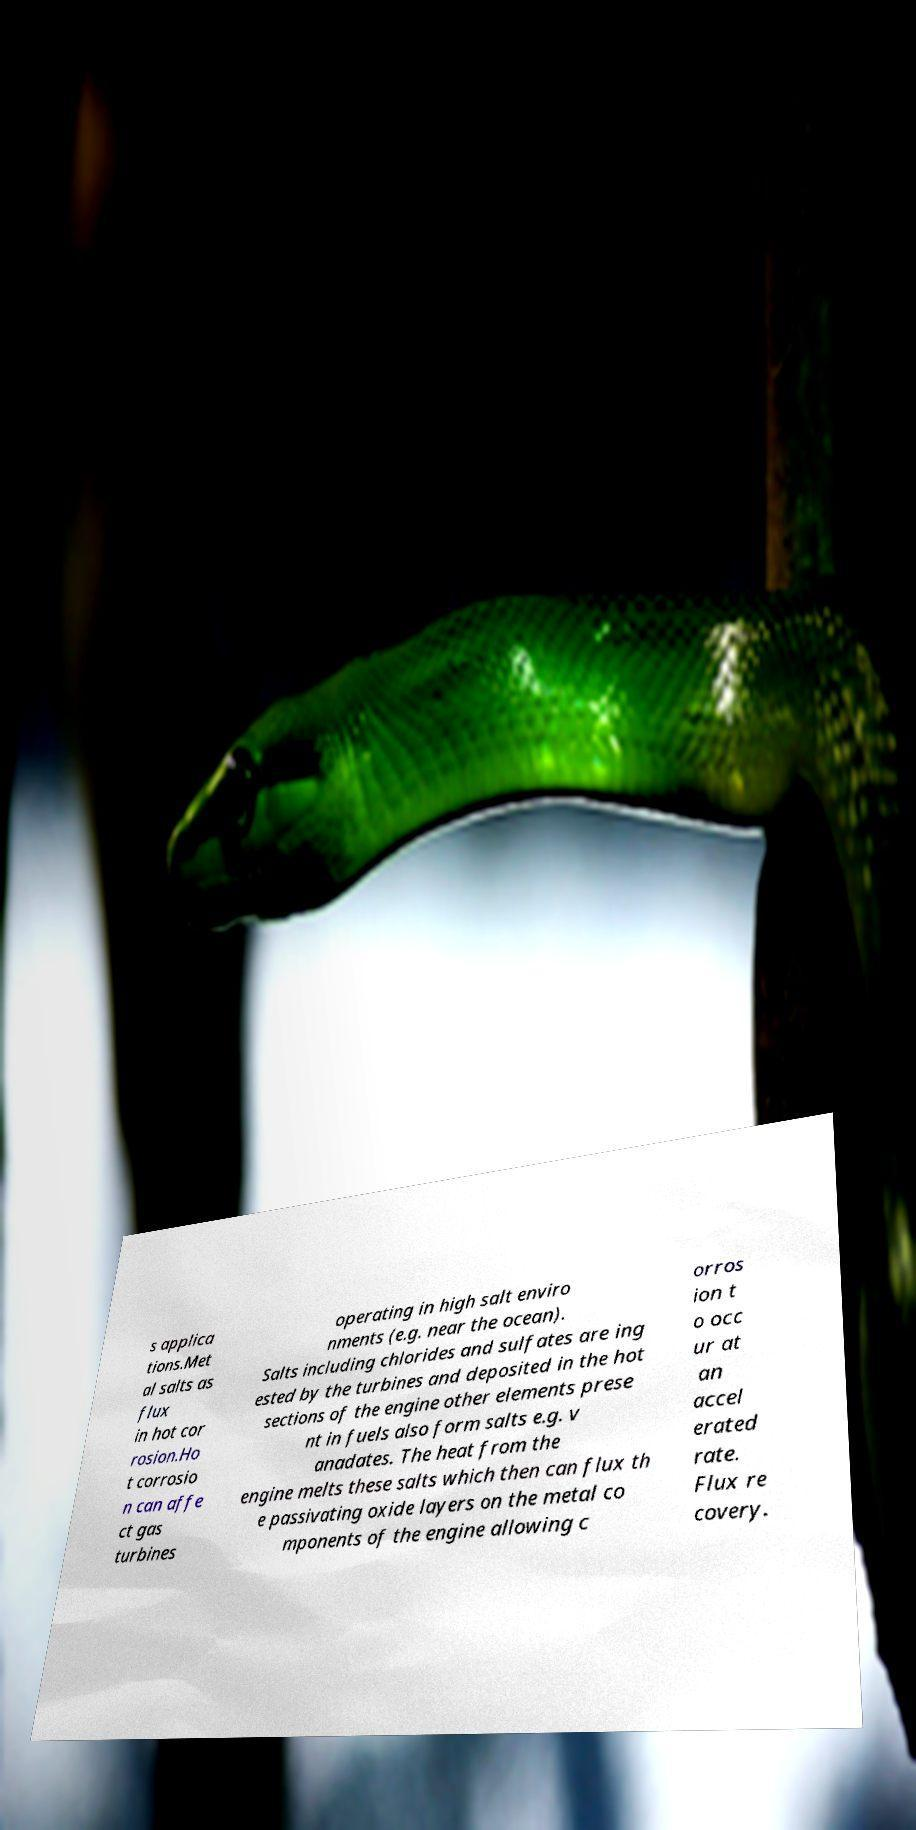What messages or text are displayed in this image? I need them in a readable, typed format. s applica tions.Met al salts as flux in hot cor rosion.Ho t corrosio n can affe ct gas turbines operating in high salt enviro nments (e.g. near the ocean). Salts including chlorides and sulfates are ing ested by the turbines and deposited in the hot sections of the engine other elements prese nt in fuels also form salts e.g. v anadates. The heat from the engine melts these salts which then can flux th e passivating oxide layers on the metal co mponents of the engine allowing c orros ion t o occ ur at an accel erated rate. Flux re covery. 